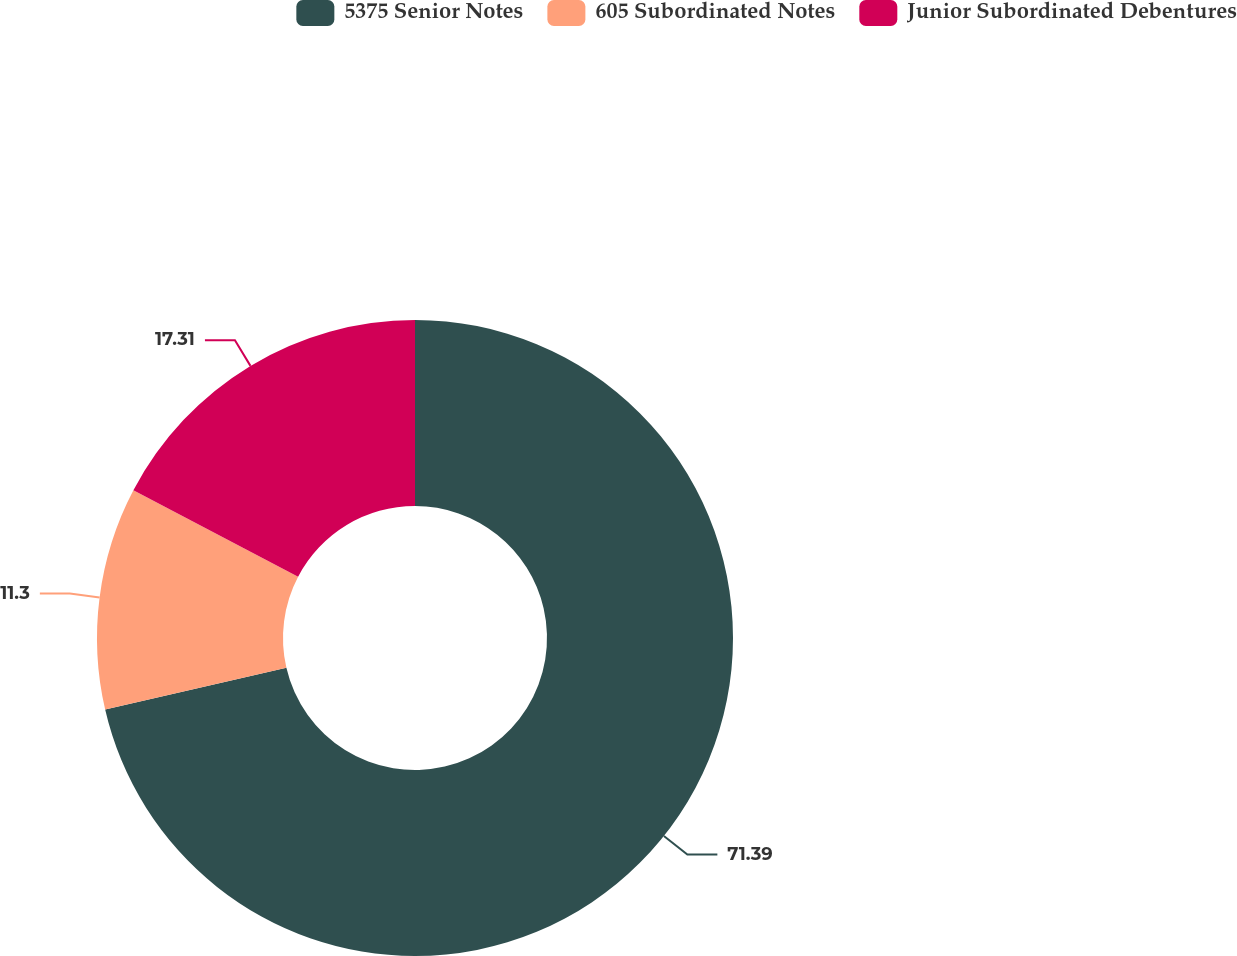<chart> <loc_0><loc_0><loc_500><loc_500><pie_chart><fcel>5375 Senior Notes<fcel>605 Subordinated Notes<fcel>Junior Subordinated Debentures<nl><fcel>71.38%<fcel>11.3%<fcel>17.31%<nl></chart> 